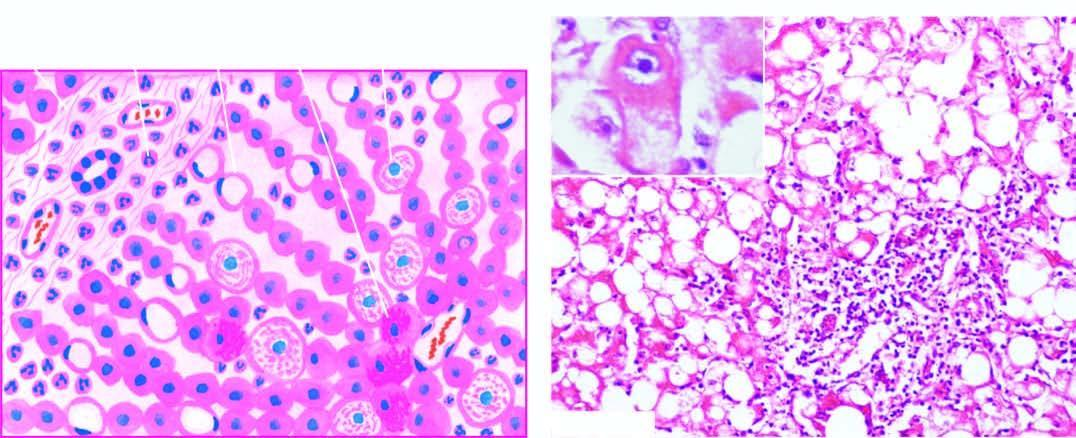do the bronchioles as well as the adjacent alveoli show ballooning degeneration and necrosis with some containing mallory 's hyalin inbox?
Answer the question using a single word or phrase. No 